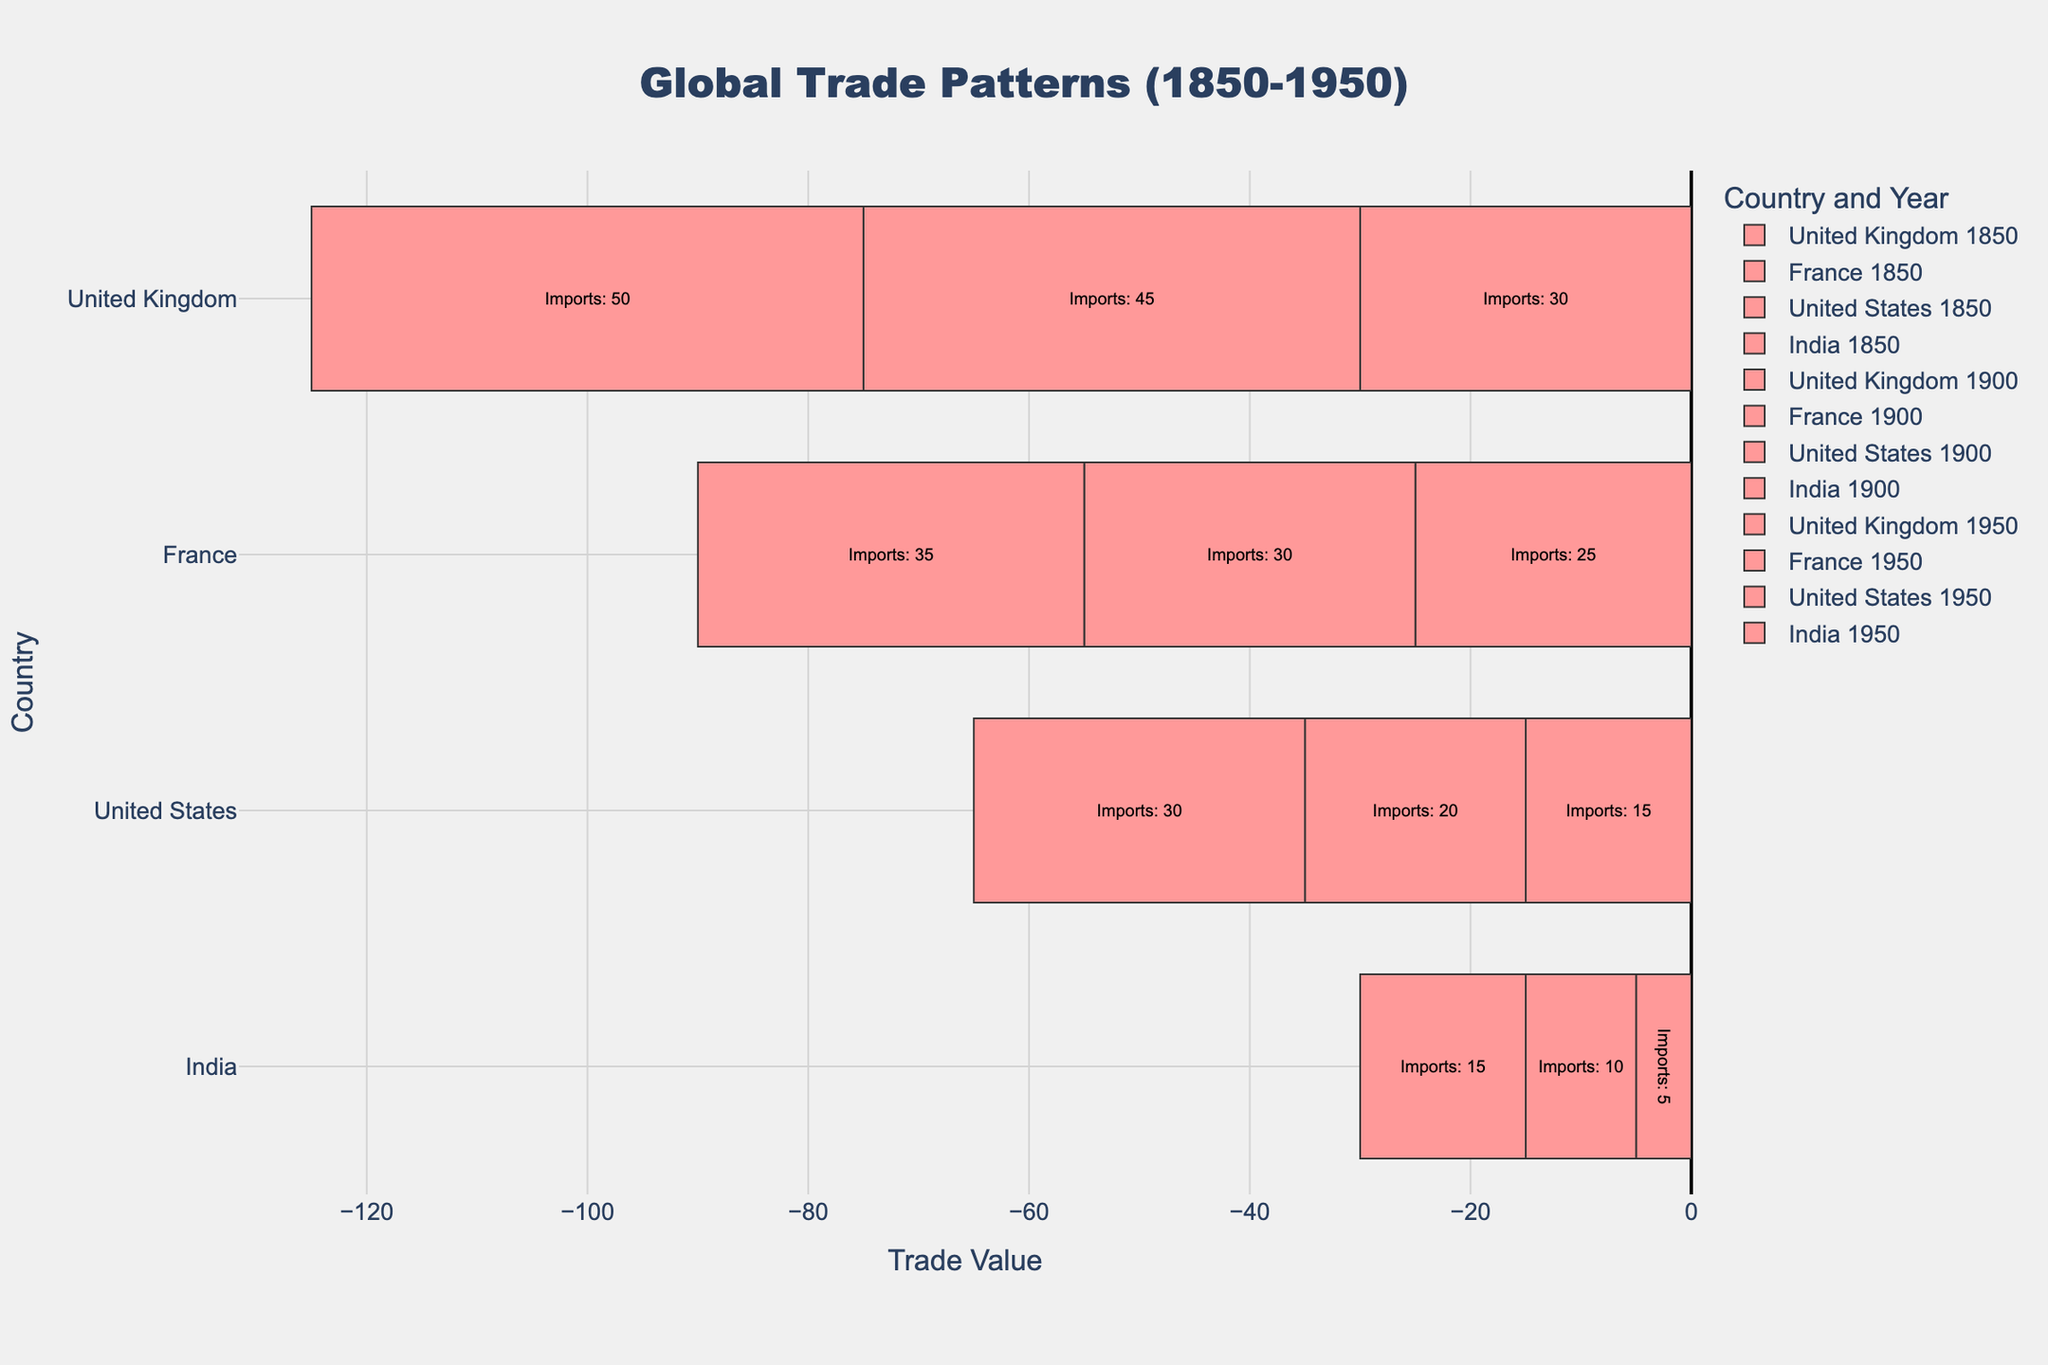What's the sum of exports and colonial trade for the United Kingdom in 1900? The export value for the United Kingdom in 1900 is 40, and the colonial trade value is 60. Summing these values gives us 40 + 60 = 100.
Answer: 100 Which country had the highest colonial trade in 1950? In 1950, the colonial trade values are 55 for the United Kingdom, 30 for France, 20 for the United States, and 30 for India. The United Kingdom had the highest colonial trade value of 55.
Answer: United Kingdom Among the years 1850, 1900, and 1950, which year shows the highest total value of imports for France? The import values for France are:
- 1850: 25
- 1900: 30
- 1950: 35
The highest total value of imports for France is in the year 1950, with a value of 35.
Answer: 1950 Which year saw the United States having a greater export value than import value? For the United States, the export and import values are:
- 1850: Exports=20, Imports=15
- 1900: Exports=30, Imports=20
- 1950: Exports=50, Imports=30
In all years (1850, 1900, 1950), the export value is greater than the import value for the United States.
Answer: 1850, 1900, 1950 What is the difference between the export values of France in 1900 and 1950? The export value for France in 1900 is 20, and in 1950 it is 25. The difference is 25 - 20 = 5.
Answer: 5 Comparing 1850 and 1950, in which year did India have a greater amount of colonial trade? The colonial trade values for India are:
- 1850: 35
- 1950: 30
India had a greater amount of colonial trade in 1850 with a value of 35.
Answer: 1850 What is the color representing exports in the chart? By visual inspection of the chart, the color representing exports is blue.
Answer: Blue 